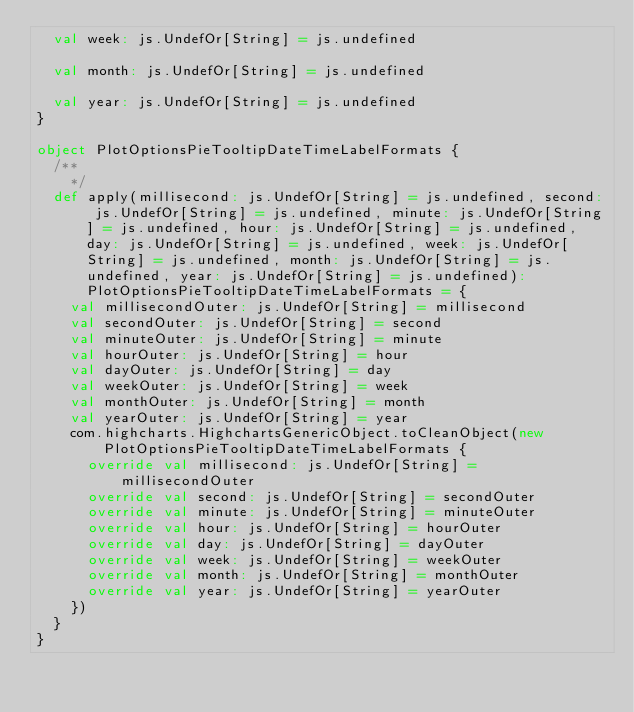<code> <loc_0><loc_0><loc_500><loc_500><_Scala_>  val week: js.UndefOr[String] = js.undefined

  val month: js.UndefOr[String] = js.undefined

  val year: js.UndefOr[String] = js.undefined
}

object PlotOptionsPieTooltipDateTimeLabelFormats {
  /**
    */
  def apply(millisecond: js.UndefOr[String] = js.undefined, second: js.UndefOr[String] = js.undefined, minute: js.UndefOr[String] = js.undefined, hour: js.UndefOr[String] = js.undefined, day: js.UndefOr[String] = js.undefined, week: js.UndefOr[String] = js.undefined, month: js.UndefOr[String] = js.undefined, year: js.UndefOr[String] = js.undefined): PlotOptionsPieTooltipDateTimeLabelFormats = {
    val millisecondOuter: js.UndefOr[String] = millisecond
    val secondOuter: js.UndefOr[String] = second
    val minuteOuter: js.UndefOr[String] = minute
    val hourOuter: js.UndefOr[String] = hour
    val dayOuter: js.UndefOr[String] = day
    val weekOuter: js.UndefOr[String] = week
    val monthOuter: js.UndefOr[String] = month
    val yearOuter: js.UndefOr[String] = year
    com.highcharts.HighchartsGenericObject.toCleanObject(new PlotOptionsPieTooltipDateTimeLabelFormats {
      override val millisecond: js.UndefOr[String] = millisecondOuter
      override val second: js.UndefOr[String] = secondOuter
      override val minute: js.UndefOr[String] = minuteOuter
      override val hour: js.UndefOr[String] = hourOuter
      override val day: js.UndefOr[String] = dayOuter
      override val week: js.UndefOr[String] = weekOuter
      override val month: js.UndefOr[String] = monthOuter
      override val year: js.UndefOr[String] = yearOuter
    })
  }
}
</code> 